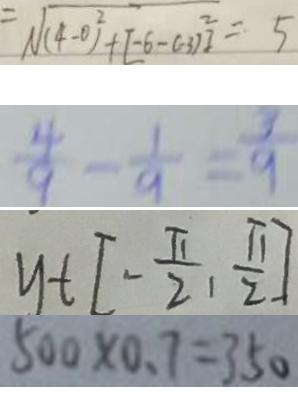Convert formula to latex. <formula><loc_0><loc_0><loc_500><loc_500>\sqrt { ( 4 - 0 ) ^ { 2 } + [ - 6 - ( 3 ) ^ { 2 } ] } = 5 
 \frac { 4 } { 9 } - \frac { 1 } { 9 } = \frac { 3 } { 9 } 
 y t [ - \frac { \pi } { 2 } , \frac { \pi } { 2 } ] 
 5 0 0 \times 0 . 7 = 3 5 0</formula> 